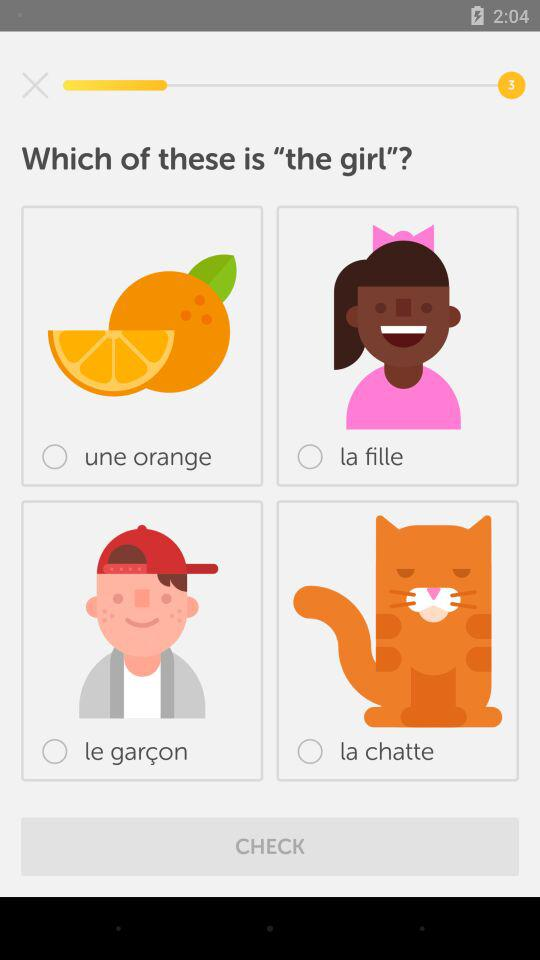Which of the following is a girl?
Answer the question using a single word or phrase. La fille 